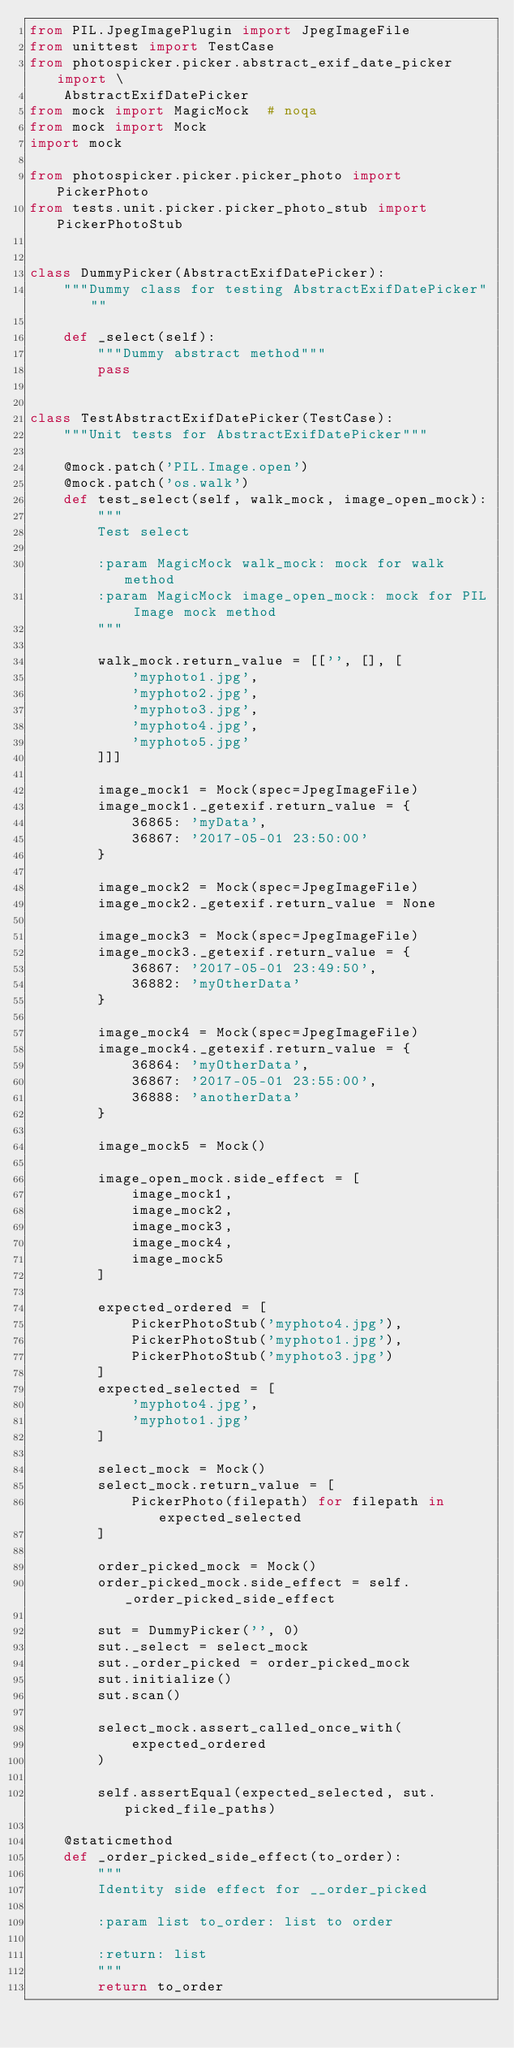<code> <loc_0><loc_0><loc_500><loc_500><_Python_>from PIL.JpegImagePlugin import JpegImageFile
from unittest import TestCase
from photospicker.picker.abstract_exif_date_picker import \
    AbstractExifDatePicker
from mock import MagicMock  # noqa
from mock import Mock
import mock

from photospicker.picker.picker_photo import PickerPhoto
from tests.unit.picker.picker_photo_stub import PickerPhotoStub


class DummyPicker(AbstractExifDatePicker):
    """Dummy class for testing AbstractExifDatePicker"""

    def _select(self):
        """Dummy abstract method"""
        pass


class TestAbstractExifDatePicker(TestCase):
    """Unit tests for AbstractExifDatePicker"""

    @mock.patch('PIL.Image.open')
    @mock.patch('os.walk')
    def test_select(self, walk_mock, image_open_mock):
        """
        Test select

        :param MagicMock walk_mock: mock for walk method
        :param MagicMock image_open_mock: mock for PIL Image mock method
        """

        walk_mock.return_value = [['', [], [
            'myphoto1.jpg',
            'myphoto2.jpg',
            'myphoto3.jpg',
            'myphoto4.jpg',
            'myphoto5.jpg'
        ]]]

        image_mock1 = Mock(spec=JpegImageFile)
        image_mock1._getexif.return_value = {
            36865: 'myData',
            36867: '2017-05-01 23:50:00'
        }

        image_mock2 = Mock(spec=JpegImageFile)
        image_mock2._getexif.return_value = None

        image_mock3 = Mock(spec=JpegImageFile)
        image_mock3._getexif.return_value = {
            36867: '2017-05-01 23:49:50',
            36882: 'myOtherData'
        }

        image_mock4 = Mock(spec=JpegImageFile)
        image_mock4._getexif.return_value = {
            36864: 'myOtherData',
            36867: '2017-05-01 23:55:00',
            36888: 'anotherData'
        }

        image_mock5 = Mock()

        image_open_mock.side_effect = [
            image_mock1,
            image_mock2,
            image_mock3,
            image_mock4,
            image_mock5
        ]

        expected_ordered = [
            PickerPhotoStub('myphoto4.jpg'),
            PickerPhotoStub('myphoto1.jpg'),
            PickerPhotoStub('myphoto3.jpg')
        ]
        expected_selected = [
            'myphoto4.jpg',
            'myphoto1.jpg'
        ]

        select_mock = Mock()
        select_mock.return_value = [
            PickerPhoto(filepath) for filepath in expected_selected
        ]

        order_picked_mock = Mock()
        order_picked_mock.side_effect = self._order_picked_side_effect

        sut = DummyPicker('', 0)
        sut._select = select_mock
        sut._order_picked = order_picked_mock
        sut.initialize()
        sut.scan()

        select_mock.assert_called_once_with(
            expected_ordered
        )

        self.assertEqual(expected_selected, sut.picked_file_paths)

    @staticmethod
    def _order_picked_side_effect(to_order):
        """
        Identity side effect for __order_picked

        :param list to_order: list to order

        :return: list
        """
        return to_order
</code> 